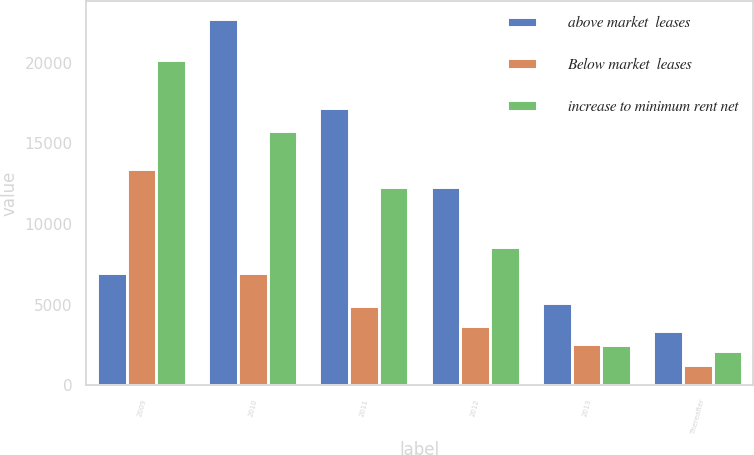Convert chart to OTSL. <chart><loc_0><loc_0><loc_500><loc_500><stacked_bar_chart><ecel><fcel>2009<fcel>2010<fcel>2011<fcel>2012<fcel>2013<fcel>Thereafter<nl><fcel>above market  leases<fcel>6958<fcel>22702<fcel>17228<fcel>12297<fcel>5105<fcel>3372<nl><fcel>Below market  leases<fcel>13388<fcel>6958<fcel>4909<fcel>3703<fcel>2592<fcel>1262<nl><fcel>increase to minimum rent net<fcel>20202<fcel>15744<fcel>12319<fcel>8594<fcel>2513<fcel>2110<nl></chart> 